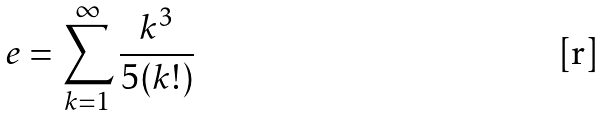Convert formula to latex. <formula><loc_0><loc_0><loc_500><loc_500>e = \sum _ { k = 1 } ^ { \infty } \frac { k ^ { 3 } } { 5 ( k ! ) }</formula> 